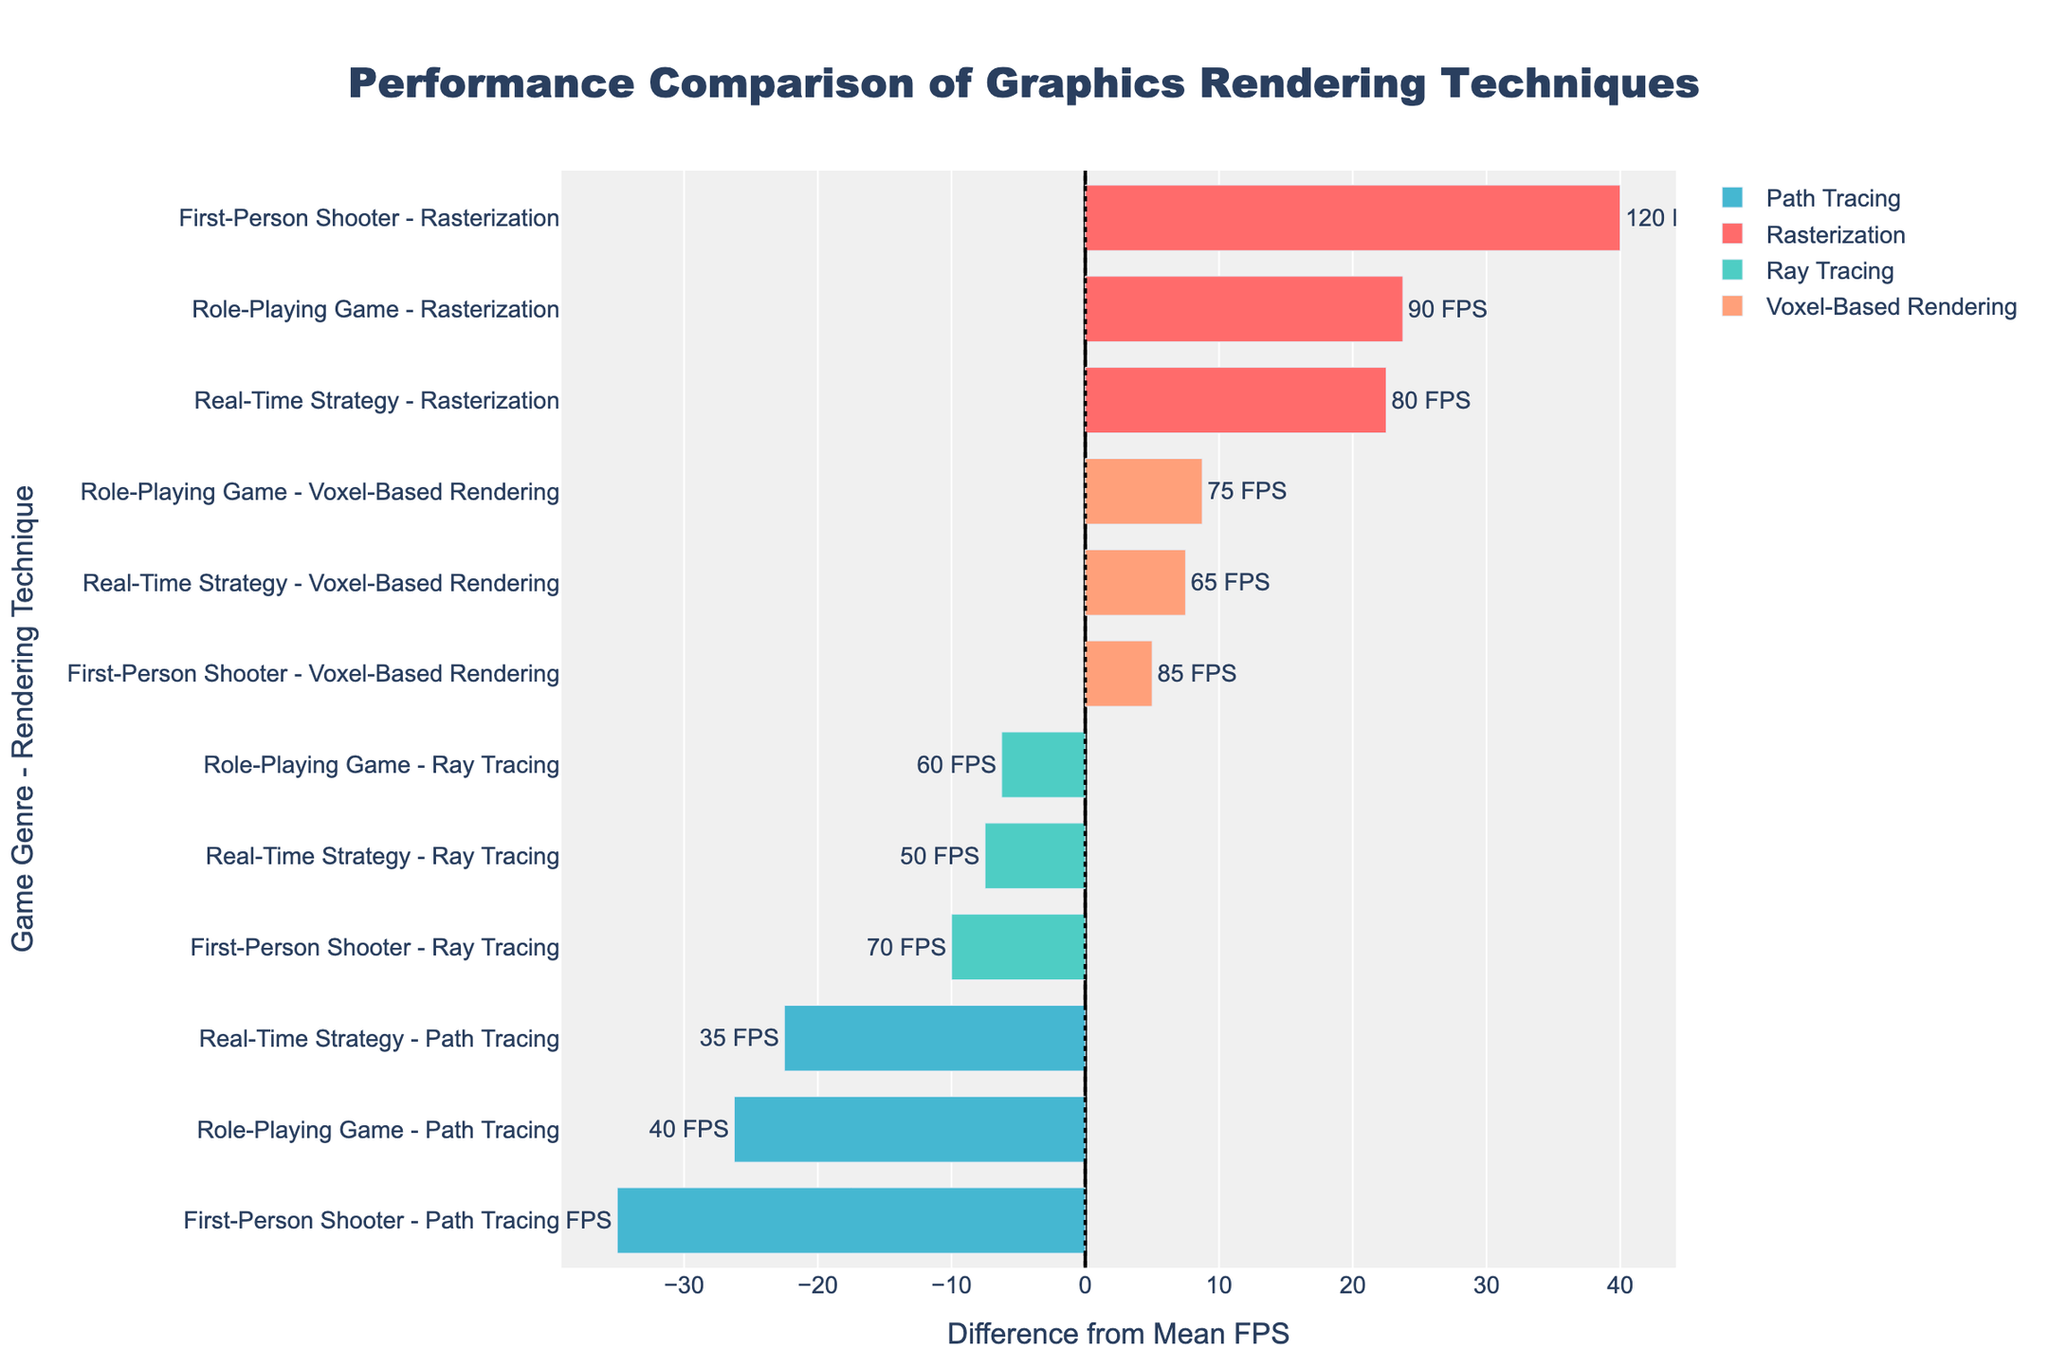Which game genre has the highest average frame rate for Rasterization? Observe the bar heights and their corresponding labels. The First-Person Shooter (FPS) genre has the highest bar for Rasterization with a frame rate of 120 FPS.
Answer: First-Person Shooter Which rendering technique shows the most significant decrease in frame rate for First-Person Shooters? Compare the bars for each rendering technique within the First-Person Shooter category. Ray Tracing shows the largest drop from Rasterization, with a frame rate of 70 FPS.
Answer: Ray Tracing What is the difference in frame rates between Voxel-Based Rendering and Path Tracing in Real-Time Strategy games? Subtract the frame rate of Path Tracing (35 FPS) from that of Voxel-Based Rendering (65 FPS) in the Real-Time Strategy category.
Answer: 30 FPS Which rendering technique has the closest frame rate to the mean frame rate in Role-Playing Games? The mean frame rate for Role-Playing Games needs to be calculated. The average for Role-Playing Games (90 + 60 + 40 + 75) / 4 is 66.25 FPS. Ray Tracing (60 FPS) is the closest to 66.25 FPS.
Answer: Ray Tracing In which game genre does Voxel-Based Rendering perform worse compared to Rasterization? Compare the bar lengths (frame rates) for Voxel-Based Rendering and Rasterization across different game genres. Voxel-Based Rendering performs worse than Rasterization in First-Person Shooters (85 vs. 120 FPS), Role-Playing Games (75 vs. 90 FPS), and Real-Time Strategy (65 vs. 80 FPS). Any genre will suffice as an answer, taking First-Person Shooter as an example.
Answer: First-Person Shooter Is the performance of Ray Tracing in Role-Playing Games above or below the average frame rate for all techniques in the same genre? Calculate the average frame rate for all techniques in the Role-Playing Game genre (90 + 60 + 40 + 75) / 4 = 66.25 FPS. Ray Tracing has a frame rate of 60 FPS, which is below the average.
Answer: Below Which rendering technique has the lowest frame rate in Real-Time Strategy games? Examine the bars in the Real-Time Strategy category. Path Tracing has the lowest frame rate with 35 FPS.
Answer: Path Tracing What is the mean frame rate difference for Path Tracing across all game genres? Calculate the mean of the frame rate differences for Path Tracing: (45-53.75) + (40-66.25) + (35-57.5). First, calculate differences: -8.75, -26.25, -22.5. Then, calculate the mean: (-8.75 - 26.25 - 22.5) / 3 = -19.17 FPS. The mean frame rate difference for Path Tracing is -19.17 FPS.
Answer: -19.17 FPS 